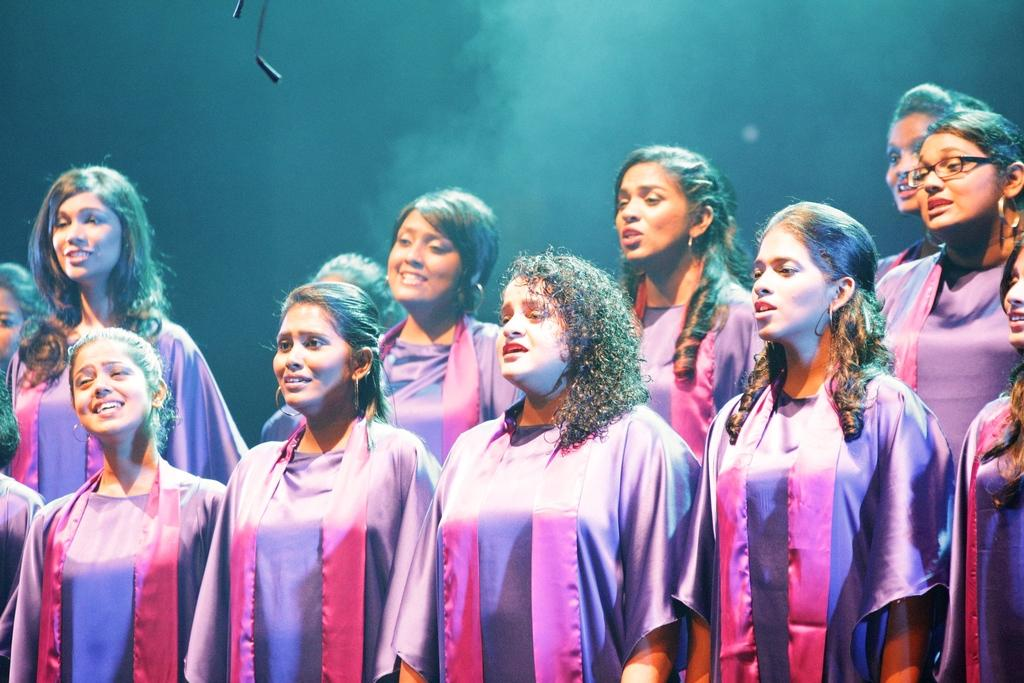What can be seen in the image? There is a group of women in the image. What are the women wearing? The women are wearing violet dresses. Can you describe any specific details about one of the women? There is a woman wearing spectacles in the image. Where is the woman wearing spectacles located in the group? The woman wearing spectacles is on the right side of the group. What type of net is being used by the women in the image? There is no net present in the image; the women are wearing violet dresses and one of them is wearing spectacles. What key is being used by the women to unlock something in the image? There is no key present in the image; the focus is on the women, their dresses, and the woman wearing spectacles. 